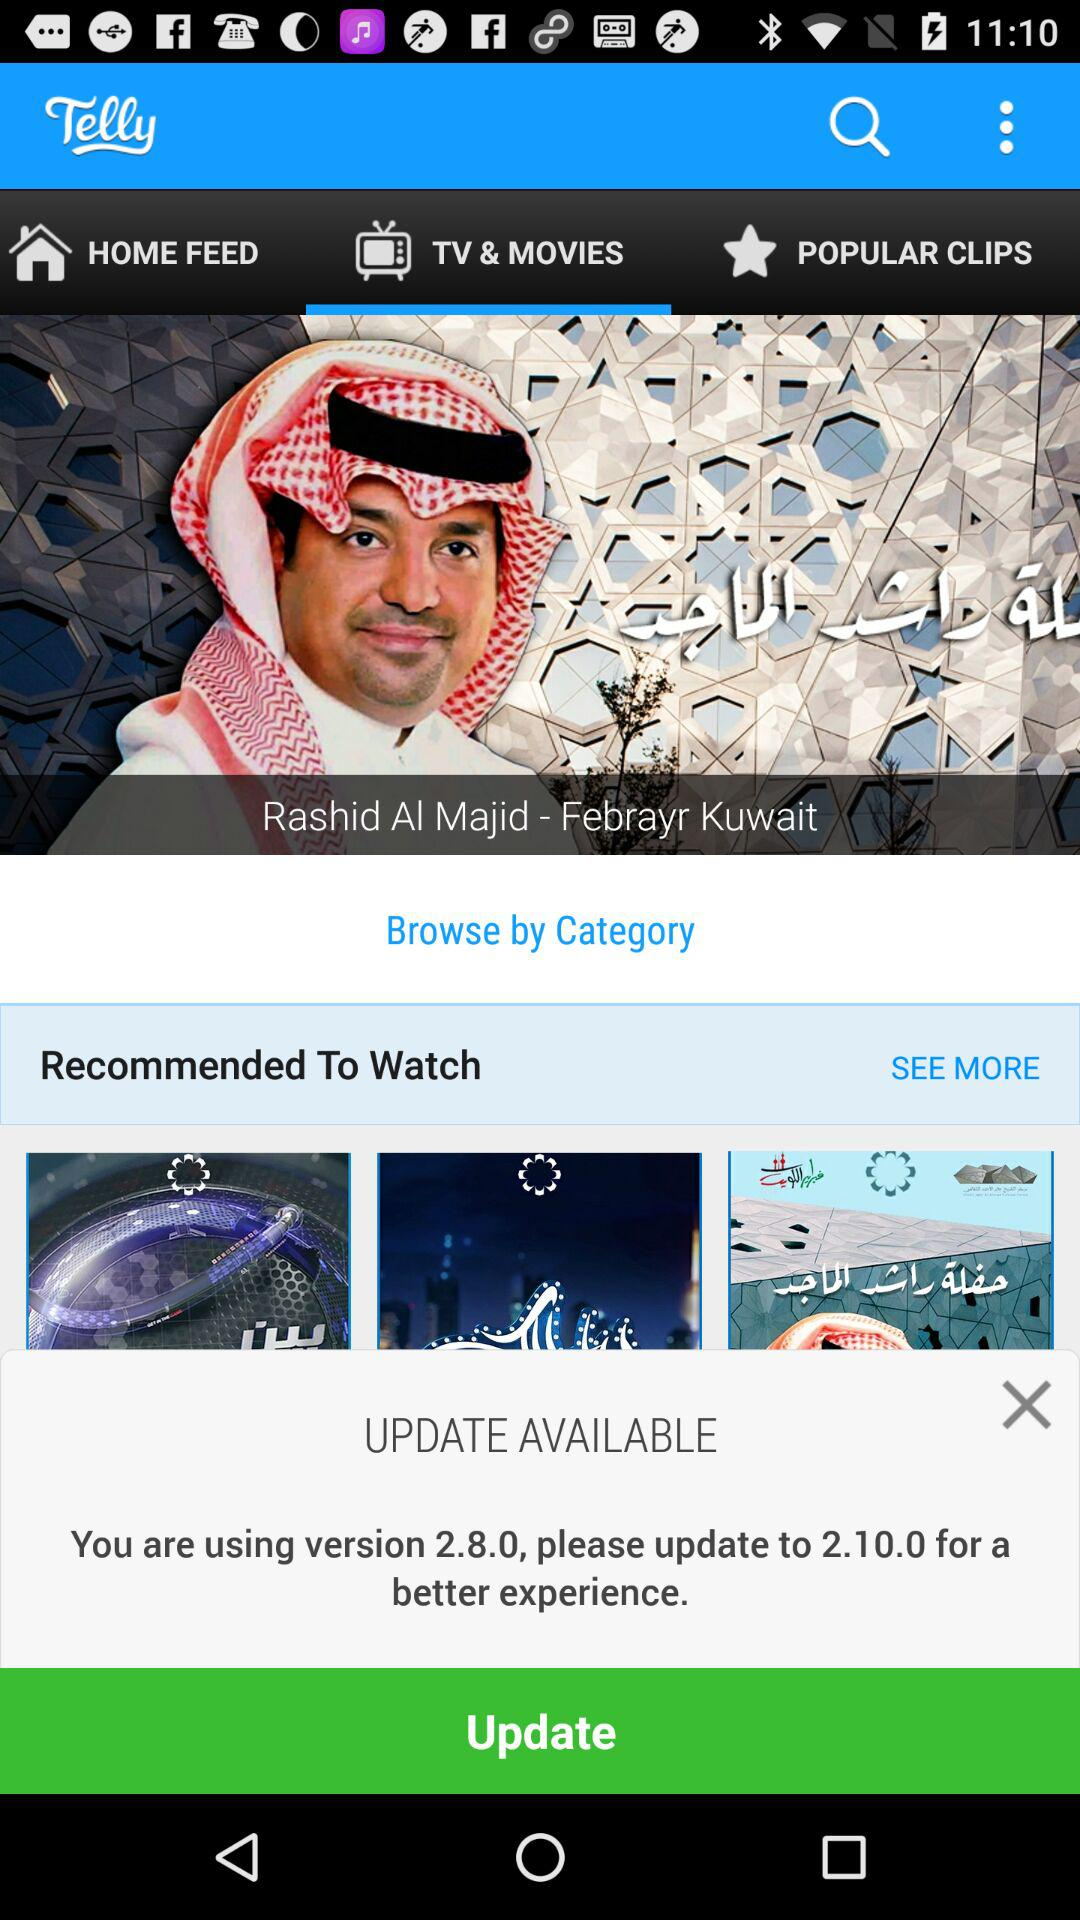How many items are listed in "HOME FEED"?
When the provided information is insufficient, respond with <no answer>. <no answer> 